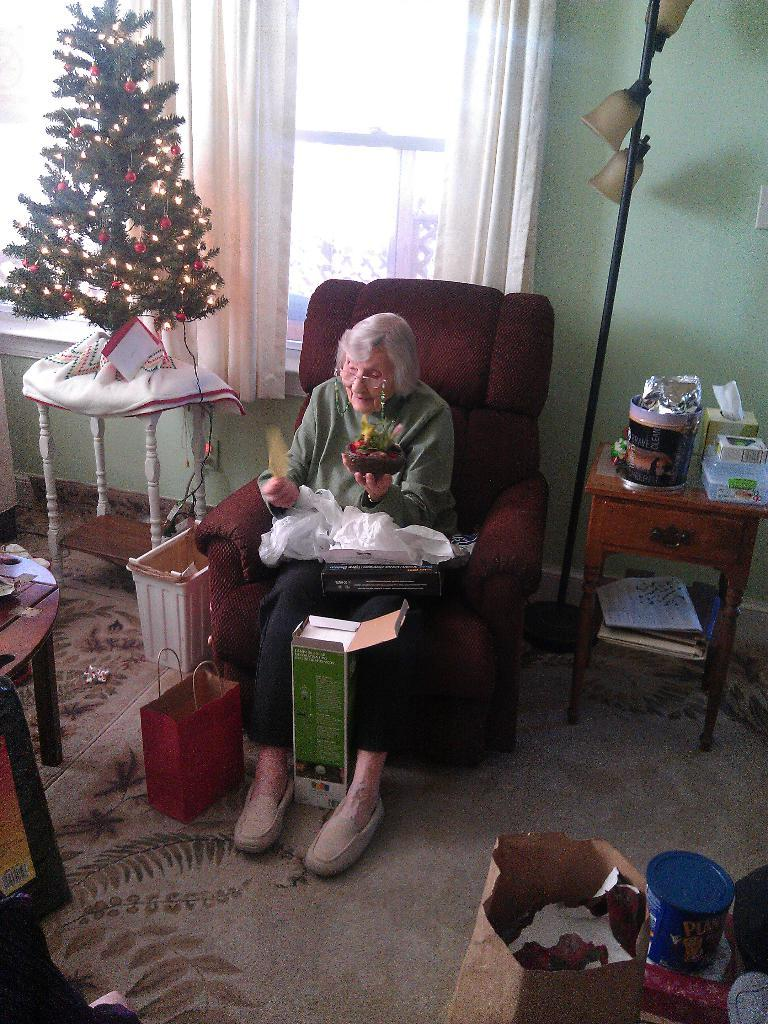What is the person in the image doing? The person is sitting on a chair. What is the person holding in the image? The person is holding things. What type of decoration is present in the image? There is a Christmas tree in the image. What part of the room can be seen in the image? The floor is visible in the image. What items are present that might be used for carrying or storing items? There are bags in the image. What type of window treatment is visible in the background? There is a curtain in the background. What architectural feature is present in the background? There is a window in the background. What type of wall is visible in the background? There is a wall in the background. What vertical structure is present in the image? There is a pole in the image. What type of trick does the person perform with the flag in the image? There is no flag present in the image, so it is not possible to answer that question. 